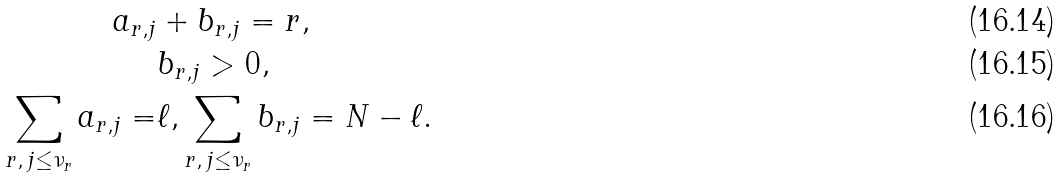<formula> <loc_0><loc_0><loc_500><loc_500>a _ { r , j } & + b _ { r , j } = r , \\ & b _ { r , j } > 0 , \\ \sum _ { r , \, j \leq \nu _ { r } } a _ { r , j } = & \ell , \sum _ { r , \, j \leq \nu _ { r } } b _ { r , j } = N - \ell .</formula> 